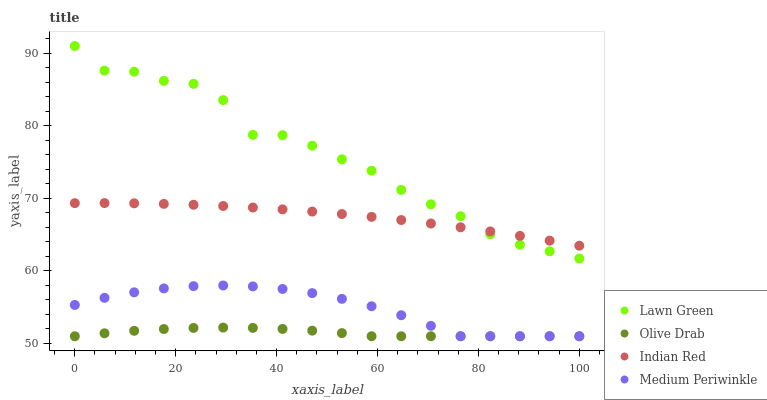Does Olive Drab have the minimum area under the curve?
Answer yes or no. Yes. Does Lawn Green have the maximum area under the curve?
Answer yes or no. Yes. Does Medium Periwinkle have the minimum area under the curve?
Answer yes or no. No. Does Medium Periwinkle have the maximum area under the curve?
Answer yes or no. No. Is Indian Red the smoothest?
Answer yes or no. Yes. Is Lawn Green the roughest?
Answer yes or no. Yes. Is Medium Periwinkle the smoothest?
Answer yes or no. No. Is Medium Periwinkle the roughest?
Answer yes or no. No. Does Medium Periwinkle have the lowest value?
Answer yes or no. Yes. Does Indian Red have the lowest value?
Answer yes or no. No. Does Lawn Green have the highest value?
Answer yes or no. Yes. Does Medium Periwinkle have the highest value?
Answer yes or no. No. Is Medium Periwinkle less than Lawn Green?
Answer yes or no. Yes. Is Indian Red greater than Medium Periwinkle?
Answer yes or no. Yes. Does Medium Periwinkle intersect Olive Drab?
Answer yes or no. Yes. Is Medium Periwinkle less than Olive Drab?
Answer yes or no. No. Is Medium Periwinkle greater than Olive Drab?
Answer yes or no. No. Does Medium Periwinkle intersect Lawn Green?
Answer yes or no. No. 